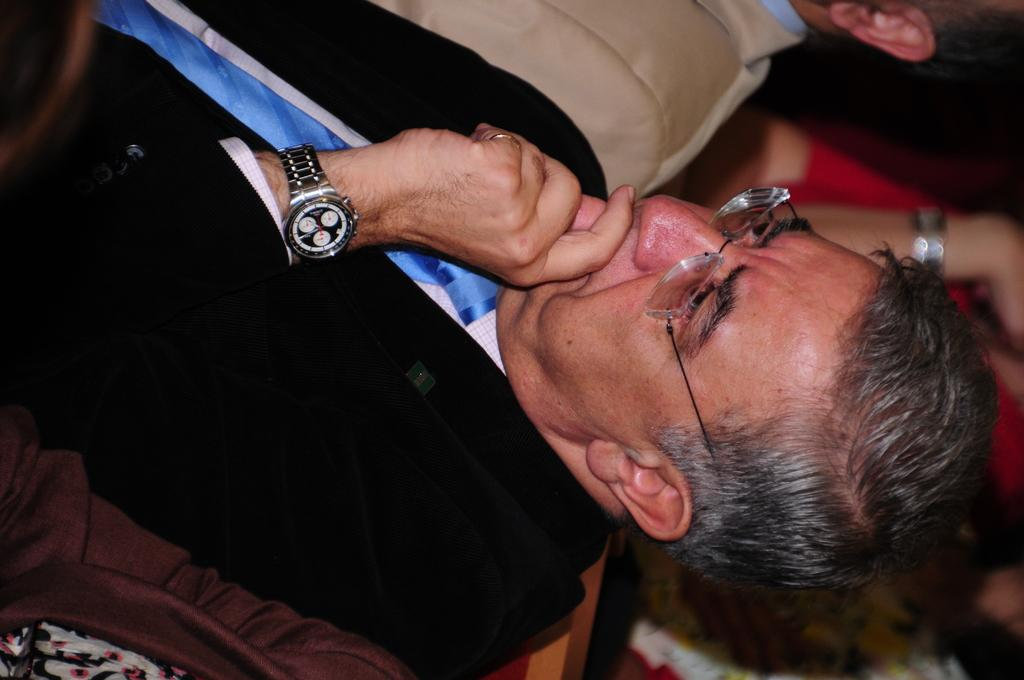What is the main subject of the image? The main subject of the image is a man. Can you describe the man's appearance? The man is wearing glasses and a watch. Are there any other people in the image? Yes, there are other persons in the image. What type of flowers can be seen in the man's hand in the image? There are no flowers present in the image, and the man's hand is not visible. What instrument is the man playing in the image? There is no instrument present in the image, and the man is not shown playing anything. 